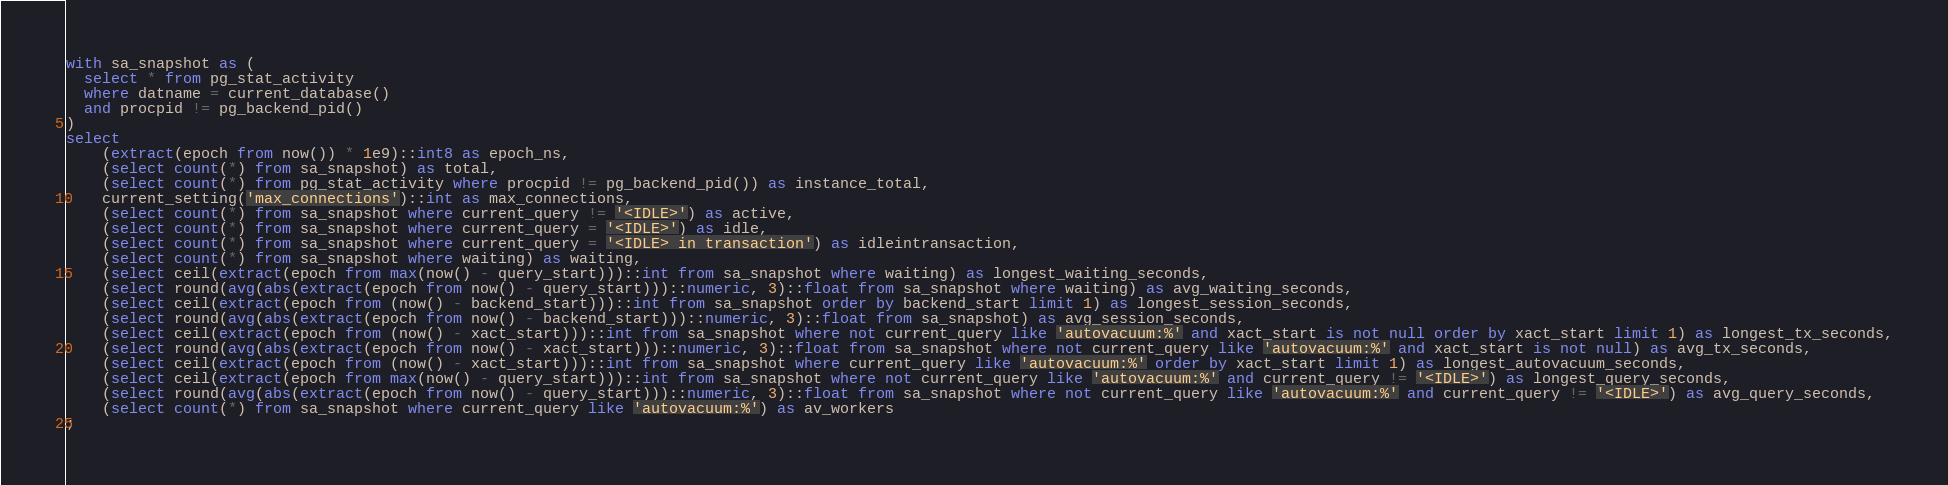<code> <loc_0><loc_0><loc_500><loc_500><_SQL_>with sa_snapshot as (
  select * from pg_stat_activity
  where datname = current_database()
  and procpid != pg_backend_pid()
)
select
    (extract(epoch from now()) * 1e9)::int8 as epoch_ns,
    (select count(*) from sa_snapshot) as total,
    (select count(*) from pg_stat_activity where procpid != pg_backend_pid()) as instance_total,
    current_setting('max_connections')::int as max_connections,
    (select count(*) from sa_snapshot where current_query != '<IDLE>') as active,
    (select count(*) from sa_snapshot where current_query = '<IDLE>') as idle,
    (select count(*) from sa_snapshot where current_query = '<IDLE> in transaction') as idleintransaction,
    (select count(*) from sa_snapshot where waiting) as waiting,
    (select ceil(extract(epoch from max(now() - query_start)))::int from sa_snapshot where waiting) as longest_waiting_seconds,
    (select round(avg(abs(extract(epoch from now() - query_start)))::numeric, 3)::float from sa_snapshot where waiting) as avg_waiting_seconds,
    (select ceil(extract(epoch from (now() - backend_start)))::int from sa_snapshot order by backend_start limit 1) as longest_session_seconds,
    (select round(avg(abs(extract(epoch from now() - backend_start)))::numeric, 3)::float from sa_snapshot) as avg_session_seconds,
    (select ceil(extract(epoch from (now() - xact_start)))::int from sa_snapshot where not current_query like 'autovacuum:%' and xact_start is not null order by xact_start limit 1) as longest_tx_seconds,
    (select round(avg(abs(extract(epoch from now() - xact_start)))::numeric, 3)::float from sa_snapshot where not current_query like 'autovacuum:%' and xact_start is not null) as avg_tx_seconds,
    (select ceil(extract(epoch from (now() - xact_start)))::int from sa_snapshot where current_query like 'autovacuum:%' order by xact_start limit 1) as longest_autovacuum_seconds,
    (select ceil(extract(epoch from max(now() - query_start)))::int from sa_snapshot where not current_query like 'autovacuum:%' and current_query != '<IDLE>') as longest_query_seconds,
    (select round(avg(abs(extract(epoch from now() - query_start)))::numeric, 3)::float from sa_snapshot where not current_query like 'autovacuum:%' and current_query != '<IDLE>') as avg_query_seconds,
    (select count(*) from sa_snapshot where current_query like 'autovacuum:%') as av_workers
;
</code> 